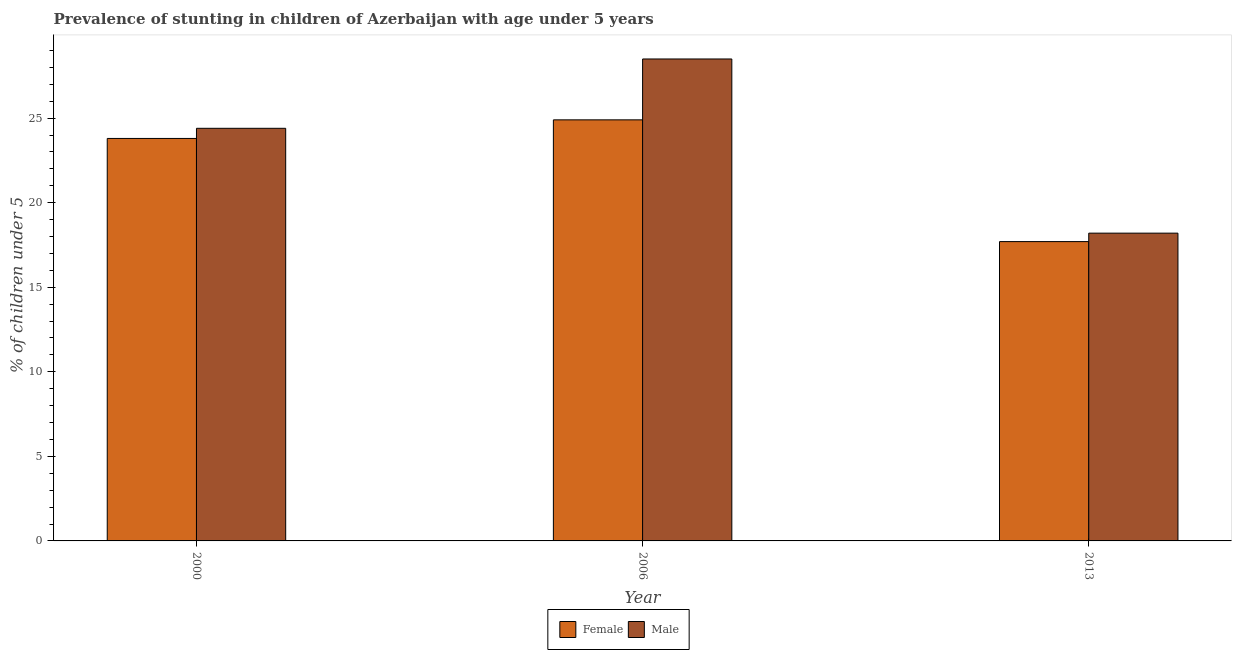How many different coloured bars are there?
Keep it short and to the point. 2. How many bars are there on the 3rd tick from the left?
Give a very brief answer. 2. How many bars are there on the 3rd tick from the right?
Offer a very short reply. 2. What is the label of the 2nd group of bars from the left?
Make the answer very short. 2006. In how many cases, is the number of bars for a given year not equal to the number of legend labels?
Your answer should be compact. 0. What is the percentage of stunted male children in 2000?
Provide a succinct answer. 24.4. Across all years, what is the maximum percentage of stunted female children?
Keep it short and to the point. 24.9. Across all years, what is the minimum percentage of stunted male children?
Provide a short and direct response. 18.2. In which year was the percentage of stunted female children minimum?
Provide a short and direct response. 2013. What is the total percentage of stunted male children in the graph?
Offer a terse response. 71.1. What is the difference between the percentage of stunted male children in 2000 and that in 2006?
Ensure brevity in your answer.  -4.1. What is the difference between the percentage of stunted male children in 2006 and the percentage of stunted female children in 2000?
Offer a terse response. 4.1. What is the average percentage of stunted male children per year?
Give a very brief answer. 23.7. In the year 2000, what is the difference between the percentage of stunted female children and percentage of stunted male children?
Your answer should be compact. 0. What is the ratio of the percentage of stunted female children in 2000 to that in 2013?
Give a very brief answer. 1.34. Is the percentage of stunted male children in 2000 less than that in 2013?
Make the answer very short. No. What is the difference between the highest and the second highest percentage of stunted male children?
Make the answer very short. 4.1. What is the difference between the highest and the lowest percentage of stunted male children?
Ensure brevity in your answer.  10.3. Is the sum of the percentage of stunted female children in 2006 and 2013 greater than the maximum percentage of stunted male children across all years?
Your answer should be compact. Yes. What does the 1st bar from the left in 2006 represents?
Offer a terse response. Female. What does the 1st bar from the right in 2006 represents?
Provide a short and direct response. Male. How many bars are there?
Provide a short and direct response. 6. Are the values on the major ticks of Y-axis written in scientific E-notation?
Your answer should be compact. No. Where does the legend appear in the graph?
Your answer should be very brief. Bottom center. How are the legend labels stacked?
Offer a terse response. Horizontal. What is the title of the graph?
Your answer should be compact. Prevalence of stunting in children of Azerbaijan with age under 5 years. What is the label or title of the Y-axis?
Provide a short and direct response.  % of children under 5. What is the  % of children under 5 in Female in 2000?
Keep it short and to the point. 23.8. What is the  % of children under 5 of Male in 2000?
Provide a succinct answer. 24.4. What is the  % of children under 5 in Female in 2006?
Give a very brief answer. 24.9. What is the  % of children under 5 of Male in 2006?
Your answer should be very brief. 28.5. What is the  % of children under 5 of Female in 2013?
Offer a very short reply. 17.7. What is the  % of children under 5 in Male in 2013?
Keep it short and to the point. 18.2. Across all years, what is the maximum  % of children under 5 in Female?
Offer a terse response. 24.9. Across all years, what is the minimum  % of children under 5 of Female?
Ensure brevity in your answer.  17.7. Across all years, what is the minimum  % of children under 5 of Male?
Your answer should be compact. 18.2. What is the total  % of children under 5 of Female in the graph?
Ensure brevity in your answer.  66.4. What is the total  % of children under 5 in Male in the graph?
Ensure brevity in your answer.  71.1. What is the difference between the  % of children under 5 in Female in 2000 and that in 2006?
Offer a terse response. -1.1. What is the difference between the  % of children under 5 of Female in 2006 and that in 2013?
Make the answer very short. 7.2. What is the difference between the  % of children under 5 of Female in 2006 and the  % of children under 5 of Male in 2013?
Offer a very short reply. 6.7. What is the average  % of children under 5 in Female per year?
Offer a very short reply. 22.13. What is the average  % of children under 5 of Male per year?
Ensure brevity in your answer.  23.7. In the year 2000, what is the difference between the  % of children under 5 in Female and  % of children under 5 in Male?
Keep it short and to the point. -0.6. What is the ratio of the  % of children under 5 of Female in 2000 to that in 2006?
Make the answer very short. 0.96. What is the ratio of the  % of children under 5 of Male in 2000 to that in 2006?
Provide a succinct answer. 0.86. What is the ratio of the  % of children under 5 in Female in 2000 to that in 2013?
Your response must be concise. 1.34. What is the ratio of the  % of children under 5 in Male in 2000 to that in 2013?
Keep it short and to the point. 1.34. What is the ratio of the  % of children under 5 of Female in 2006 to that in 2013?
Your response must be concise. 1.41. What is the ratio of the  % of children under 5 in Male in 2006 to that in 2013?
Give a very brief answer. 1.57. What is the difference between the highest and the second highest  % of children under 5 in Female?
Give a very brief answer. 1.1. What is the difference between the highest and the lowest  % of children under 5 of Male?
Give a very brief answer. 10.3. 